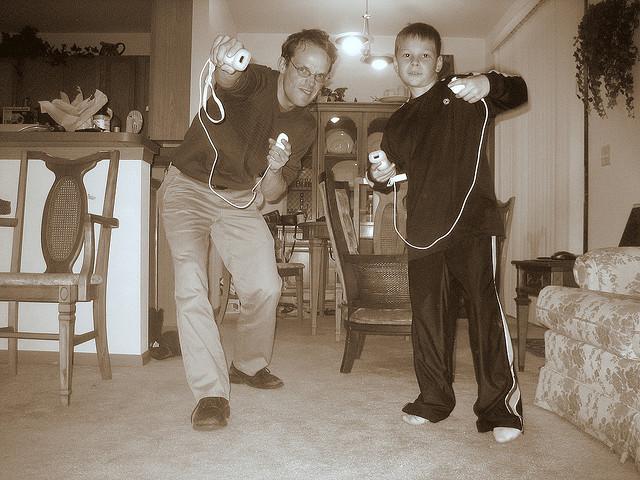Is this a furniture store?
Short answer required. No. What gaming system are the two people using?
Keep it brief. Wii. Is there any color in this photo?
Answer briefly. No. How many stools are there?
Answer briefly. 0. What is the color scheme of the photo?
Write a very short answer. Black and white. 